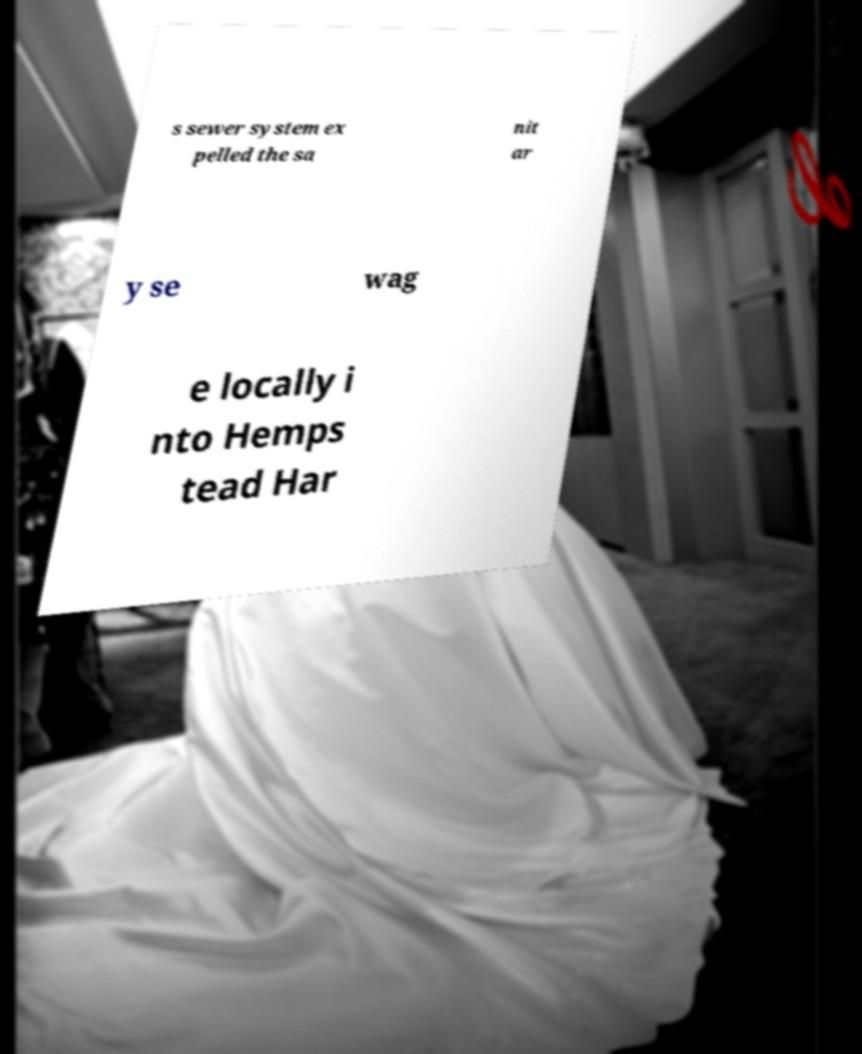Could you assist in decoding the text presented in this image and type it out clearly? s sewer system ex pelled the sa nit ar y se wag e locally i nto Hemps tead Har 